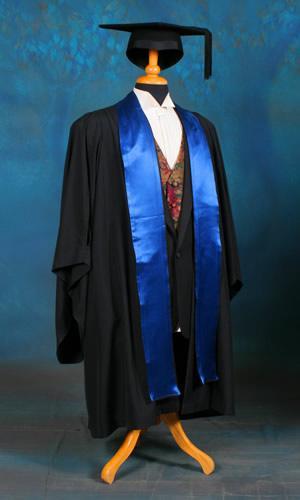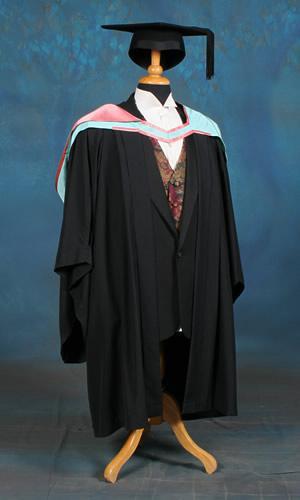The first image is the image on the left, the second image is the image on the right. For the images shown, is this caption "The left image shows exactly one male in graduation garb." true? Answer yes or no. No. 